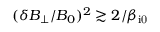<formula> <loc_0><loc_0><loc_500><loc_500>( \delta B _ { \perp } / B _ { 0 } ) ^ { 2 } \gtrsim 2 / \beta _ { i 0 }</formula> 